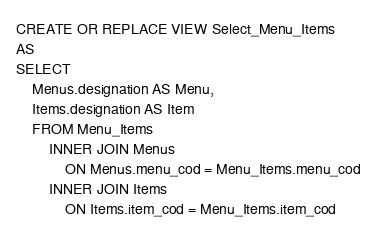<code> <loc_0><loc_0><loc_500><loc_500><_SQL_>CREATE OR REPLACE VIEW Select_Menu_Items
AS
SELECT 
    Menus.designation AS Menu, 
    Items.designation AS Item
    FROM Menu_Items
        INNER JOIN Menus
            ON Menus.menu_cod = Menu_Items.menu_cod
        INNER JOIN Items
            ON Items.item_cod = Menu_Items.item_cod</code> 